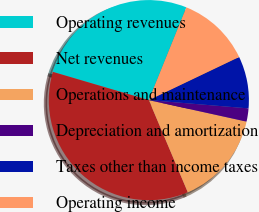Convert chart to OTSL. <chart><loc_0><loc_0><loc_500><loc_500><pie_chart><fcel>Operating revenues<fcel>Net revenues<fcel>Operations and maintenance<fcel>Depreciation and amortization<fcel>Taxes other than income taxes<fcel>Operating income<nl><fcel>26.57%<fcel>35.92%<fcel>15.19%<fcel>2.13%<fcel>8.41%<fcel>11.79%<nl></chart> 